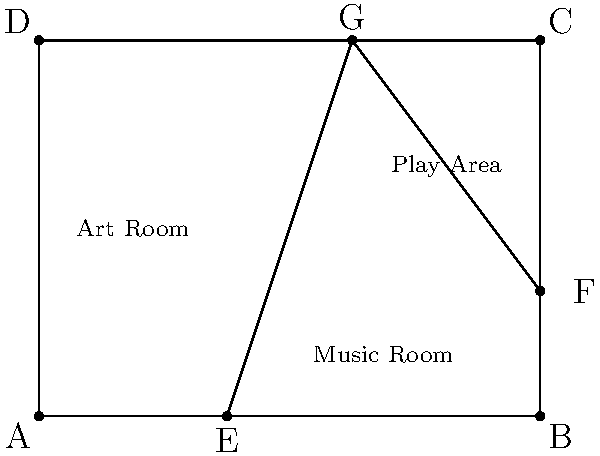In the floor plan of the community center's activity rooms shown above, angle EGF is formed by the walls separating the Art Room, Music Room, and Play Area. If the measure of angle AGD is 60°, what is the measure of angle EGF? To find the measure of angle EGF, we can follow these steps:

1) First, note that ABCD is a rectangle, so all its angles are 90°.

2) In triangle AGD:
   - We're given that angle AGD is 60°
   - Angle GAD is 90° (as it's an angle of the rectangle)
   - The sum of angles in a triangle is always 180°
   
   So, angle AGL = 180° - 90° - 60° = 30°

3) Angle EGF is supplementary to angle AGD (they form a straight line)
   Supplementary angles add up to 180°

4) Therefore:
   Measure of angle EGF = 180° - Measure of angle AGD
                        = 180° - 60°
                        = 120°

Thus, the measure of angle EGF is 120°.
Answer: $120°$ 